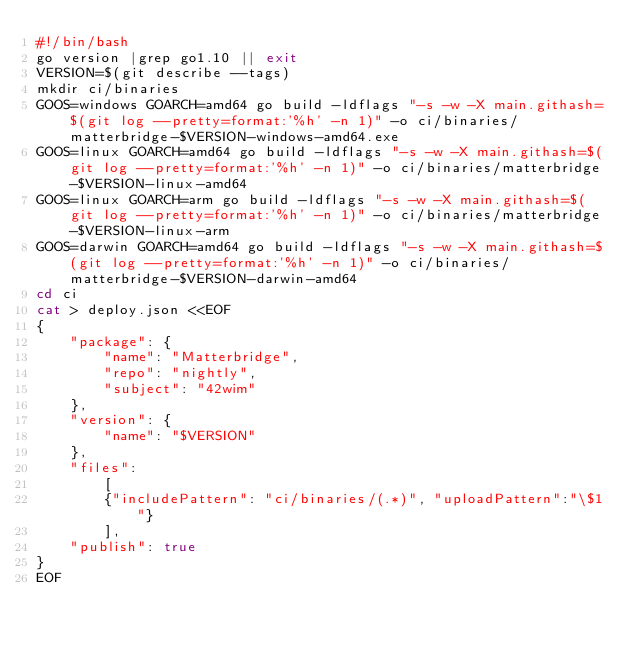Convert code to text. <code><loc_0><loc_0><loc_500><loc_500><_Bash_>#!/bin/bash
go version |grep go1.10 || exit
VERSION=$(git describe --tags)
mkdir ci/binaries
GOOS=windows GOARCH=amd64 go build -ldflags "-s -w -X main.githash=$(git log --pretty=format:'%h' -n 1)" -o ci/binaries/matterbridge-$VERSION-windows-amd64.exe
GOOS=linux GOARCH=amd64 go build -ldflags "-s -w -X main.githash=$(git log --pretty=format:'%h' -n 1)" -o ci/binaries/matterbridge-$VERSION-linux-amd64
GOOS=linux GOARCH=arm go build -ldflags "-s -w -X main.githash=$(git log --pretty=format:'%h' -n 1)" -o ci/binaries/matterbridge-$VERSION-linux-arm
GOOS=darwin GOARCH=amd64 go build -ldflags "-s -w -X main.githash=$(git log --pretty=format:'%h' -n 1)" -o ci/binaries/matterbridge-$VERSION-darwin-amd64
cd ci
cat > deploy.json <<EOF
{
    "package": {
        "name": "Matterbridge",
        "repo": "nightly",
        "subject": "42wim"
    },
    "version": {
        "name": "$VERSION"
    },
    "files":
        [
        {"includePattern": "ci/binaries/(.*)", "uploadPattern":"\$1"}
        ],
    "publish": true
}
EOF

</code> 